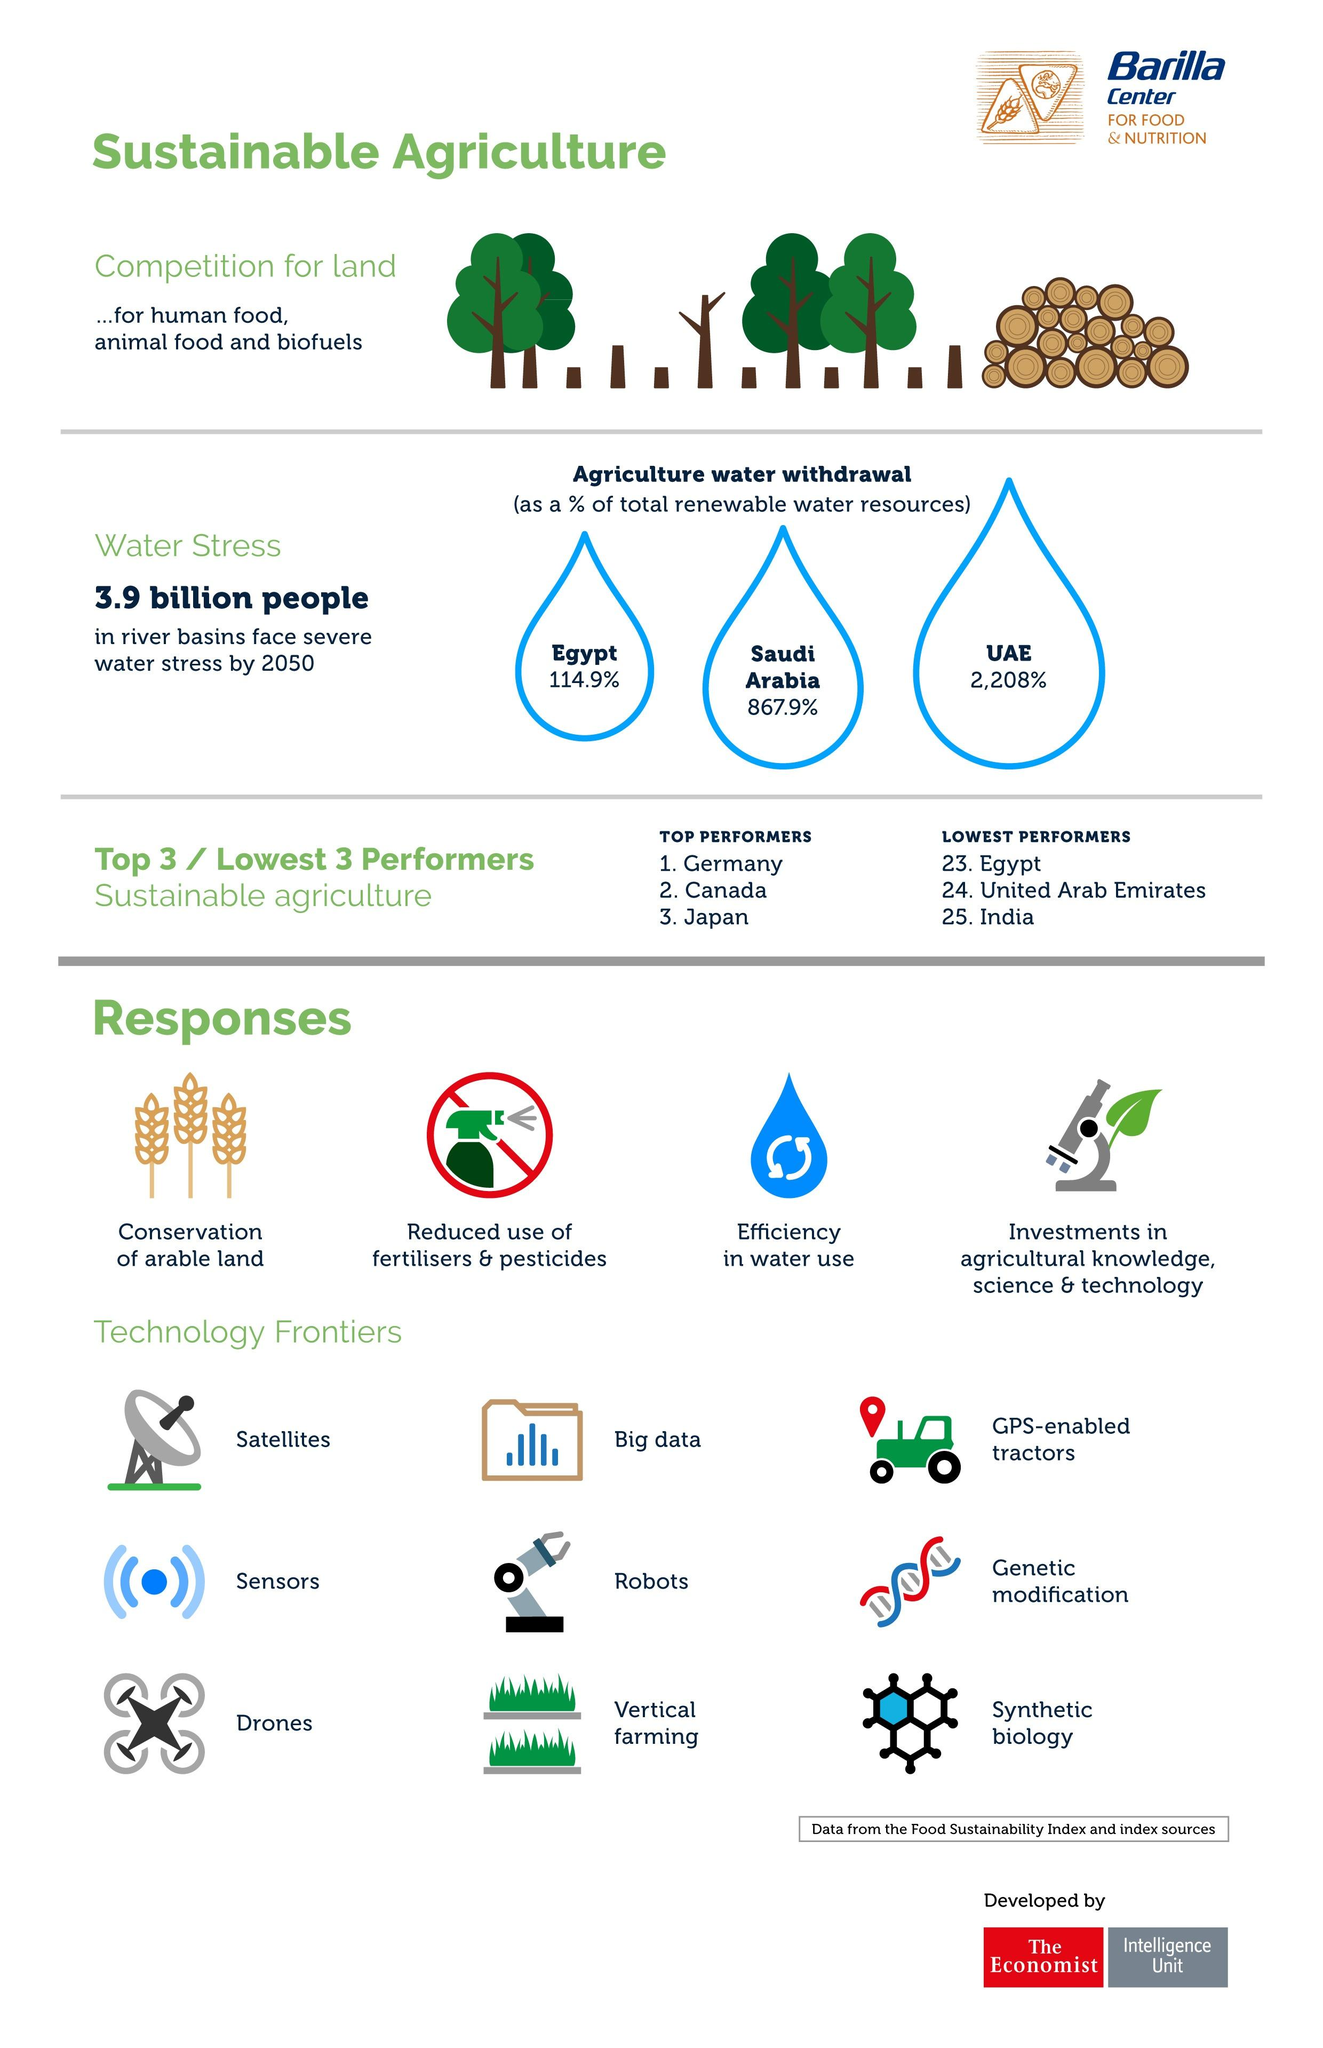Point out several critical features in this image. Numerous methods have been identified in the technology frontier 9.. India has lower performance than the United Arab Emirates. Robots and big data can be used in a wide range of applications, including technology frontiers. Four types of responses have been identified. The agriculture water withdrawal for the United Arab Emirates is 2,208%. 